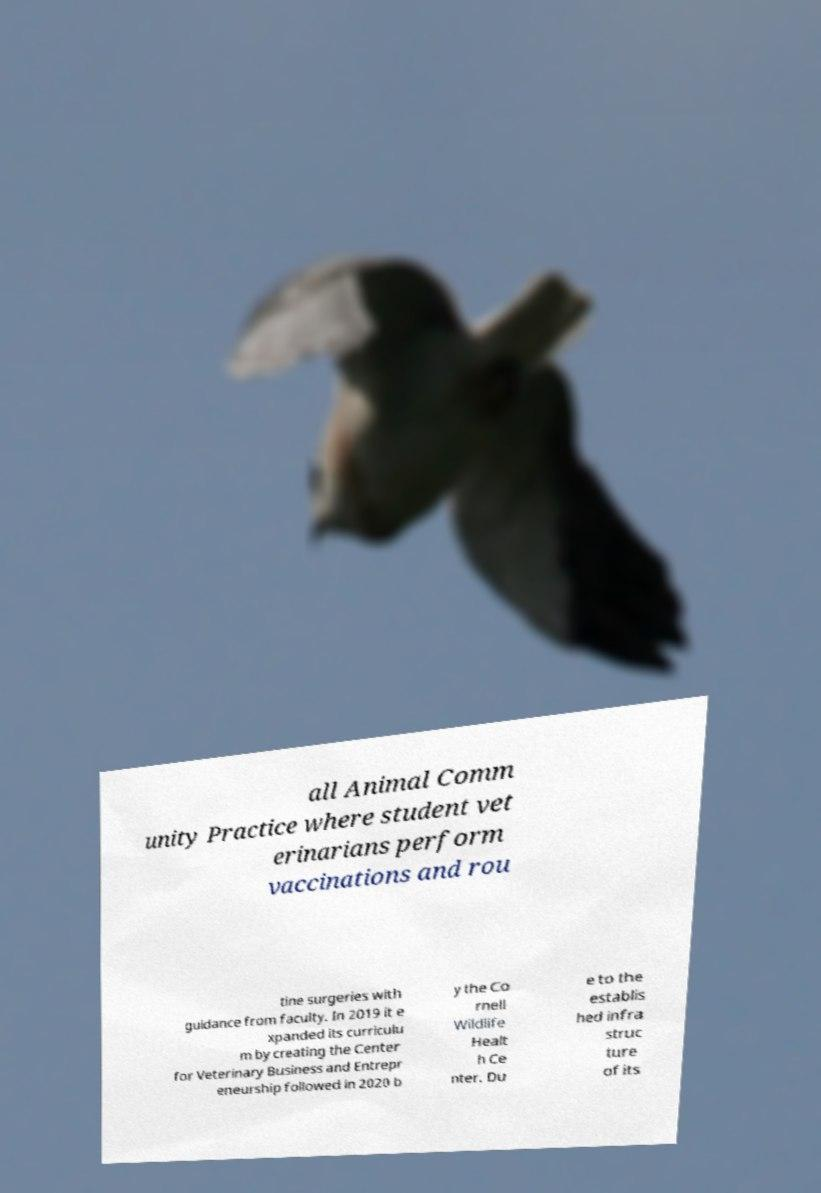Can you accurately transcribe the text from the provided image for me? all Animal Comm unity Practice where student vet erinarians perform vaccinations and rou tine surgeries with guidance from faculty. In 2019 it e xpanded its curriculu m by creating the Center for Veterinary Business and Entrepr eneurship followed in 2020 b y the Co rnell Wildlife Healt h Ce nter. Du e to the establis hed infra struc ture of its 